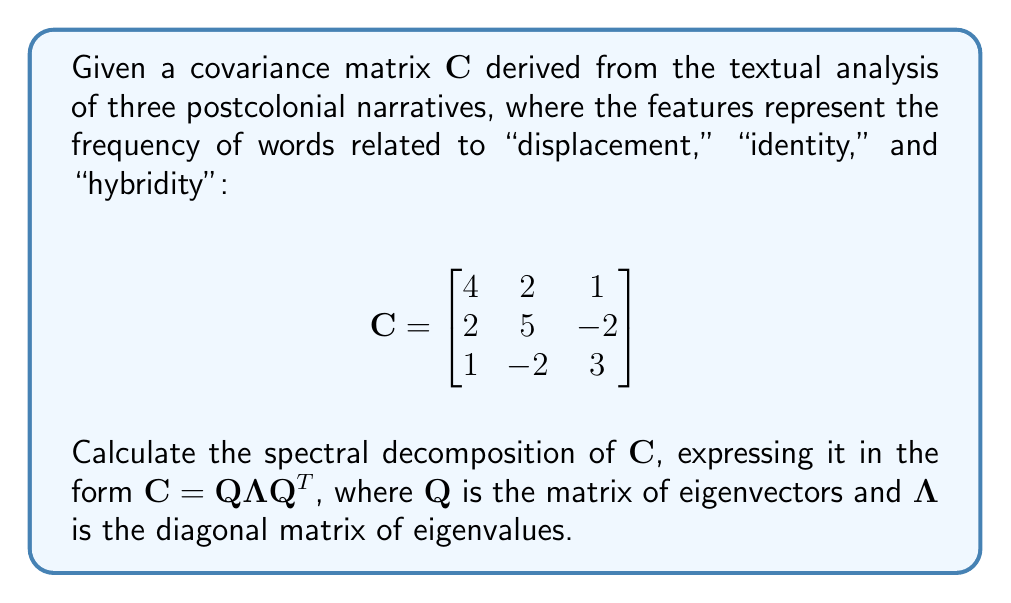Solve this math problem. To find the spectral decomposition of the covariance matrix $\mathbf{C}$, we need to follow these steps:

1) Find the eigenvalues of $\mathbf{C}$:
   - Compute the characteristic equation: $\det(\mathbf{C} - \lambda\mathbf{I}) = 0$
   - Solve for $\lambda$

2) Find the eigenvectors corresponding to each eigenvalue:
   - For each $\lambda$, solve $(\mathbf{C} - \lambda\mathbf{I})\mathbf{v} = \mathbf{0}$

3) Construct the matrices $\mathbf{Q}$ and $\mathbf{\Lambda}$

Step 1: Finding eigenvalues

The characteristic equation is:
$$\det(\mathbf{C} - \lambda\mathbf{I}) = \begin{vmatrix}
4-\lambda & 2 & 1 \\
2 & 5-\lambda & -2 \\
1 & -2 & 3-\lambda
\end{vmatrix} = 0$$

Expanding this determinant:
$$(4-\lambda)(5-\lambda)(3-\lambda) + 2(-2) + 1(2) - (4-\lambda)(-2)^2 - (5-\lambda) - (3-\lambda)(2)^2 = 0$$

Simplifying:
$$-\lambda^3 + 12\lambda^2 - 41\lambda + 42 = 0$$

The roots of this equation are the eigenvalues:
$\lambda_1 = 7$, $\lambda_2 = 3$, $\lambda_3 = 2$

Step 2: Finding eigenvectors

For $\lambda_1 = 7$:
$$(\mathbf{C} - 7\mathbf{I})\mathbf{v}_1 = \mathbf{0}$$
$$\begin{bmatrix}
-3 & 2 & 1 \\
2 & -2 & -2 \\
1 & -2 & -4
\end{bmatrix}\mathbf{v}_1 = \mathbf{0}$$

Solving this system, we get: $\mathbf{v}_1 = (2, 2, 1)^T$

Similarly, for $\lambda_2 = 3$ and $\lambda_3 = 2$, we get:
$\mathbf{v}_2 = (-1, 0, 1)^T$ and $\mathbf{v}_3 = (0, 1, 1)^T$

Step 3: Constructing $\mathbf{Q}$ and $\mathbf{\Lambda}$

Normalizing the eigenvectors:
$$\mathbf{q}_1 = \frac{1}{3}(2, 2, 1)^T$$
$$\mathbf{q}_2 = \frac{1}{\sqrt{2}}(-1, 0, 1)^T$$
$$\mathbf{q}_3 = \frac{1}{\sqrt{2}}(0, 1, 1)^T$$

Now we can form $\mathbf{Q}$ and $\mathbf{\Lambda}$:

$$\mathbf{Q} = \begin{bmatrix}
\frac{2}{3} & -\frac{1}{\sqrt{2}} & 0 \\
\frac{2}{3} & 0 & \frac{1}{\sqrt{2}} \\
\frac{1}{3} & \frac{1}{\sqrt{2}} & \frac{1}{\sqrt{2}}
\end{bmatrix}$$

$$\mathbf{\Lambda} = \begin{bmatrix}
7 & 0 & 0 \\
0 & 3 & 0 \\
0 & 0 & 2
\end{bmatrix}$$
Answer: $\mathbf{C} = \mathbf{Q}\mathbf{\Lambda}\mathbf{Q}^T$, where

$\mathbf{Q} = \begin{bmatrix}
\frac{2}{3} & -\frac{1}{\sqrt{2}} & 0 \\
\frac{2}{3} & 0 & \frac{1}{\sqrt{2}} \\
\frac{1}{3} & \frac{1}{\sqrt{2}} & \frac{1}{\sqrt{2}}
\end{bmatrix}$, 

$\mathbf{\Lambda} = \begin{bmatrix}
7 & 0 & 0 \\
0 & 3 & 0 \\
0 & 0 & 2
\end{bmatrix}$ 